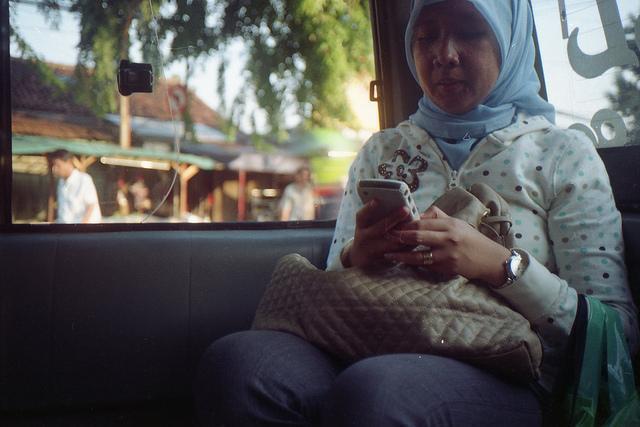How many human faces are visible in this picture?
Give a very brief answer. 3. How many people are there?
Give a very brief answer. 2. 